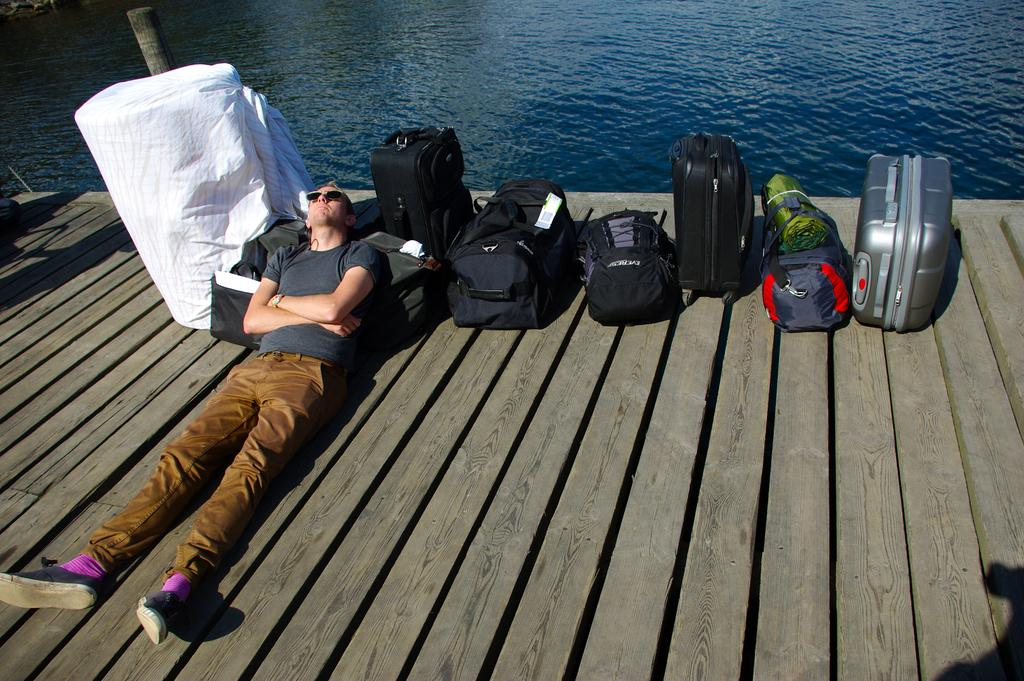What is the man in the image doing? The man is lying on a wooden raft in the image. What can be seen in the middle of the raft? There are bags in the middle of the raft. What is visible in the background of the image? There is water visible in the background of the image. What is located on the left side of the image? There is a cloth on the left side of the image. What type of low range vehicle is the man driving in the image? There is no vehicle present in the image; the man is lying on a wooden raft. What does the man's dad say about the raft in the image? There is no mention of the man's dad in the image, so it is not possible to answer that question. 